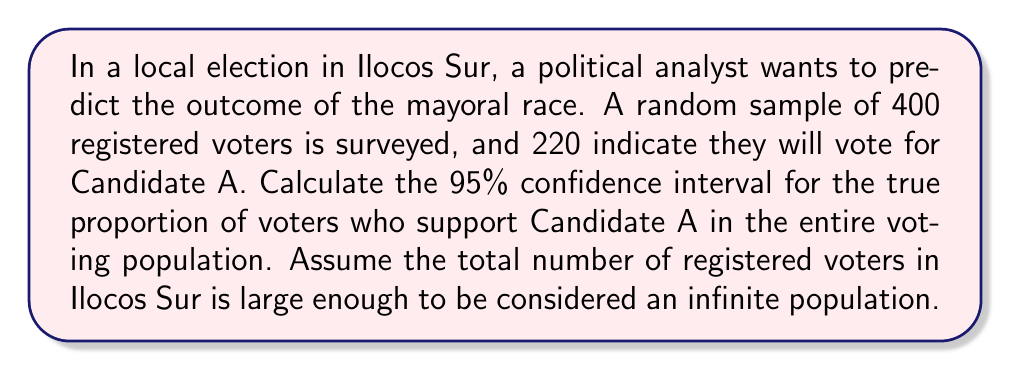Can you solve this math problem? To calculate the confidence interval, we'll use the formula for a 95% confidence interval for a proportion:

$$p \pm z \sqrt{\frac{p(1-p)}{n}}$$

Where:
$p$ = sample proportion
$z$ = z-score for 95% confidence level (1.96)
$n$ = sample size

Step 1: Calculate the sample proportion ($p$)
$p = \frac{220}{400} = 0.55$

Step 2: Calculate the standard error
$$SE = \sqrt{\frac{p(1-p)}{n}} = \sqrt{\frac{0.55(1-0.55)}{400}} = 0.0249$$

Step 3: Calculate the margin of error
$$ME = z \times SE = 1.96 \times 0.0249 = 0.0488$$

Step 4: Calculate the confidence interval
Lower bound: $0.55 - 0.0488 = 0.5012$
Upper bound: $0.55 + 0.0488 = 0.5988$

Therefore, the 95% confidence interval is (0.5012, 0.5988) or (50.12%, 59.88%).

This means we can be 95% confident that the true proportion of voters who support Candidate A in the entire voting population of Ilocos Sur is between 50.12% and 59.88%.
Answer: The 95% confidence interval for the true proportion of voters who support Candidate A is (0.5012, 0.5988) or (50.12%, 59.88%). 